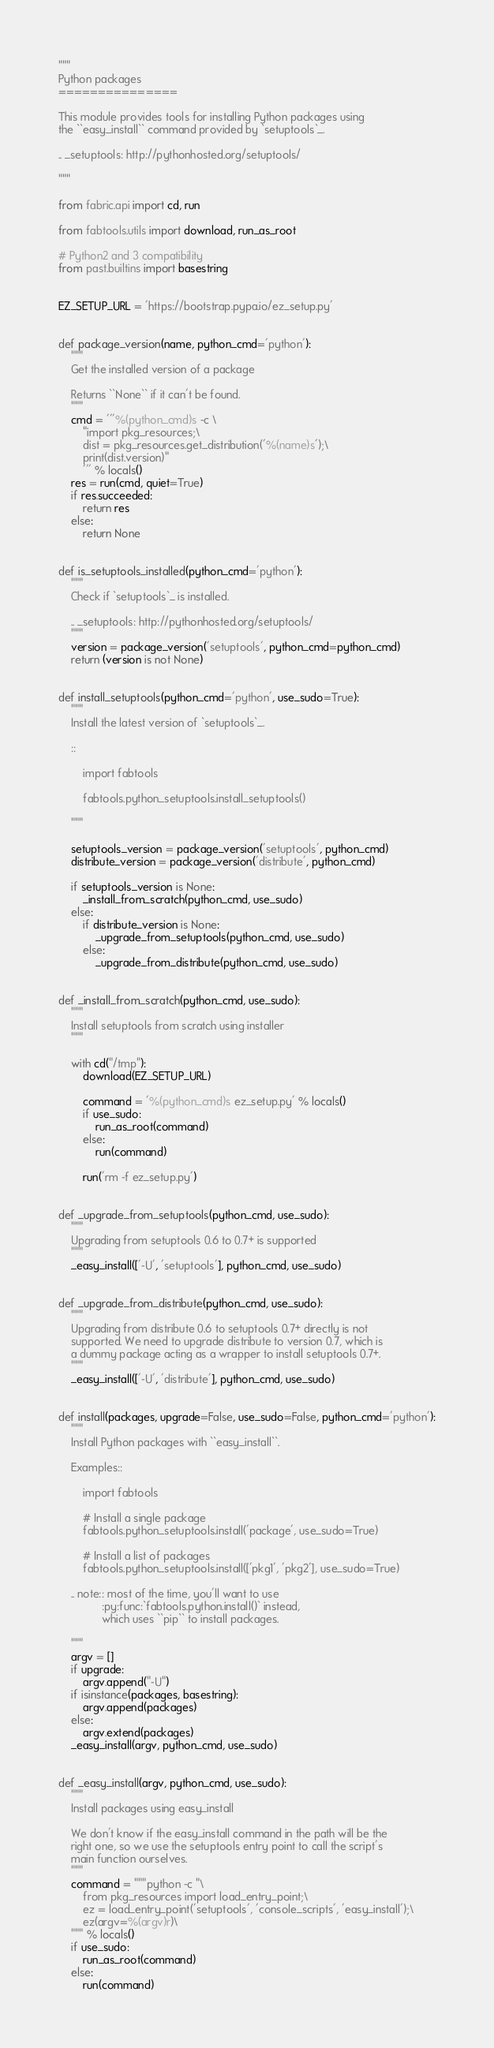<code> <loc_0><loc_0><loc_500><loc_500><_Python_>"""
Python packages
===============

This module provides tools for installing Python packages using
the ``easy_install`` command provided by `setuptools`_.

.. _setuptools: http://pythonhosted.org/setuptools/

"""

from fabric.api import cd, run

from fabtools.utils import download, run_as_root

# Python2 and 3 compatibility
from past.builtins import basestring


EZ_SETUP_URL = 'https://bootstrap.pypa.io/ez_setup.py'


def package_version(name, python_cmd='python'):
    """
    Get the installed version of a package

    Returns ``None`` if it can't be found.
    """
    cmd = '''%(python_cmd)s -c \
        "import pkg_resources;\
        dist = pkg_resources.get_distribution('%(name)s');\
        print(dist.version)"
        ''' % locals()
    res = run(cmd, quiet=True)
    if res.succeeded:
        return res
    else:
        return None


def is_setuptools_installed(python_cmd='python'):
    """
    Check if `setuptools`_ is installed.

    .. _setuptools: http://pythonhosted.org/setuptools/
    """
    version = package_version('setuptools', python_cmd=python_cmd)
    return (version is not None)


def install_setuptools(python_cmd='python', use_sudo=True):
    """
    Install the latest version of `setuptools`_.

    ::

        import fabtools

        fabtools.python_setuptools.install_setuptools()

    """

    setuptools_version = package_version('setuptools', python_cmd)
    distribute_version = package_version('distribute', python_cmd)

    if setuptools_version is None:
        _install_from_scratch(python_cmd, use_sudo)
    else:
        if distribute_version is None:
            _upgrade_from_setuptools(python_cmd, use_sudo)
        else:
            _upgrade_from_distribute(python_cmd, use_sudo)


def _install_from_scratch(python_cmd, use_sudo):
    """
    Install setuptools from scratch using installer
    """

    with cd("/tmp"):
        download(EZ_SETUP_URL)

        command = '%(python_cmd)s ez_setup.py' % locals()
        if use_sudo:
            run_as_root(command)
        else:
            run(command)

        run('rm -f ez_setup.py')


def _upgrade_from_setuptools(python_cmd, use_sudo):
    """
    Upgrading from setuptools 0.6 to 0.7+ is supported
    """
    _easy_install(['-U', 'setuptools'], python_cmd, use_sudo)


def _upgrade_from_distribute(python_cmd, use_sudo):
    """
    Upgrading from distribute 0.6 to setuptools 0.7+ directly is not
    supported. We need to upgrade distribute to version 0.7, which is
    a dummy package acting as a wrapper to install setuptools 0.7+.
    """
    _easy_install(['-U', 'distribute'], python_cmd, use_sudo)


def install(packages, upgrade=False, use_sudo=False, python_cmd='python'):
    """
    Install Python packages with ``easy_install``.

    Examples::

        import fabtools

        # Install a single package
        fabtools.python_setuptools.install('package', use_sudo=True)

        # Install a list of packages
        fabtools.python_setuptools.install(['pkg1', 'pkg2'], use_sudo=True)

    .. note:: most of the time, you'll want to use
              :py:func:`fabtools.python.install()` instead,
              which uses ``pip`` to install packages.

    """
    argv = []
    if upgrade:
        argv.append("-U")
    if isinstance(packages, basestring):
        argv.append(packages)
    else:
        argv.extend(packages)
    _easy_install(argv, python_cmd, use_sudo)


def _easy_install(argv, python_cmd, use_sudo):
    """
    Install packages using easy_install

    We don't know if the easy_install command in the path will be the
    right one, so we use the setuptools entry point to call the script's
    main function ourselves.
    """
    command = """python -c "\
        from pkg_resources import load_entry_point;\
        ez = load_entry_point('setuptools', 'console_scripts', 'easy_install');\
        ez(argv=%(argv)r)\
    """ % locals()
    if use_sudo:
        run_as_root(command)
    else:
        run(command)
</code> 